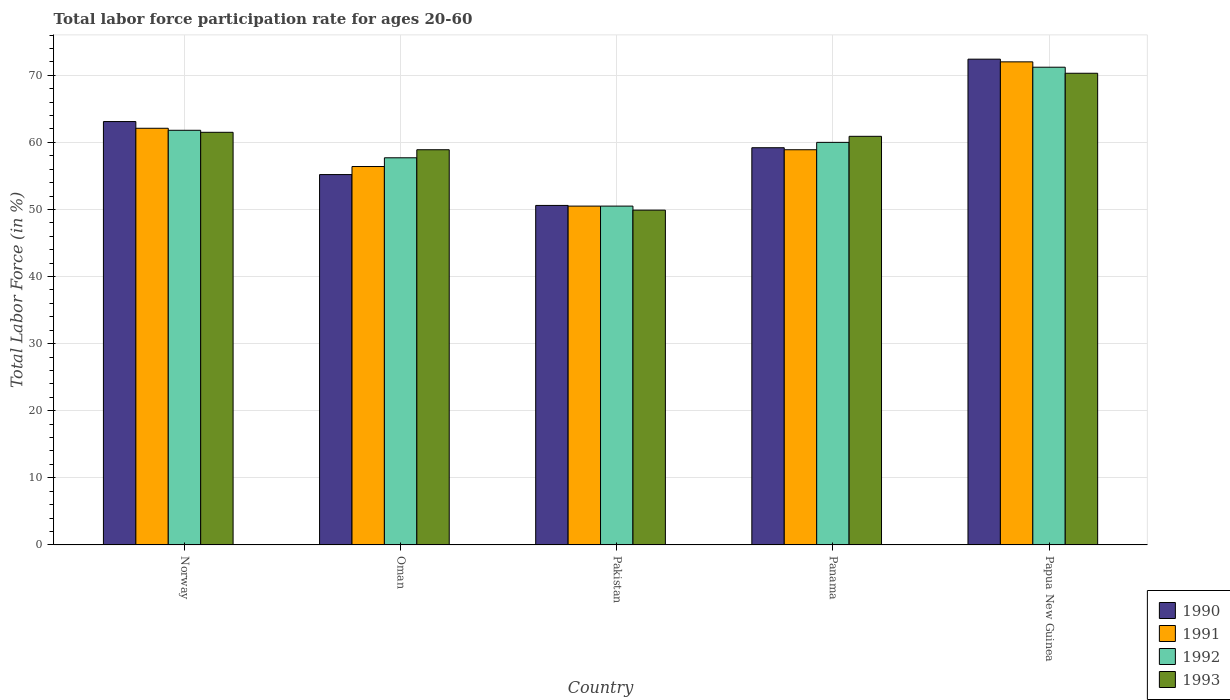Are the number of bars per tick equal to the number of legend labels?
Provide a short and direct response. Yes. Are the number of bars on each tick of the X-axis equal?
Provide a short and direct response. Yes. What is the label of the 5th group of bars from the left?
Your response must be concise. Papua New Guinea. In how many cases, is the number of bars for a given country not equal to the number of legend labels?
Offer a very short reply. 0. What is the labor force participation rate in 1991 in Panama?
Offer a very short reply. 58.9. Across all countries, what is the maximum labor force participation rate in 1990?
Provide a short and direct response. 72.4. Across all countries, what is the minimum labor force participation rate in 1993?
Make the answer very short. 49.9. In which country was the labor force participation rate in 1993 maximum?
Make the answer very short. Papua New Guinea. What is the total labor force participation rate in 1993 in the graph?
Offer a very short reply. 301.5. What is the difference between the labor force participation rate in 1992 in Panama and the labor force participation rate in 1991 in Papua New Guinea?
Offer a terse response. -12. What is the average labor force participation rate in 1990 per country?
Your answer should be compact. 60.1. What is the difference between the labor force participation rate of/in 1993 and labor force participation rate of/in 1990 in Oman?
Your answer should be very brief. 3.7. In how many countries, is the labor force participation rate in 1993 greater than 54 %?
Your answer should be very brief. 4. What is the ratio of the labor force participation rate in 1991 in Oman to that in Panama?
Keep it short and to the point. 0.96. What is the difference between the highest and the second highest labor force participation rate in 1991?
Keep it short and to the point. 13.1. What is the difference between the highest and the lowest labor force participation rate in 1992?
Provide a short and direct response. 20.7. Is the sum of the labor force participation rate in 1992 in Norway and Oman greater than the maximum labor force participation rate in 1993 across all countries?
Make the answer very short. Yes. How many bars are there?
Offer a terse response. 20. How many countries are there in the graph?
Your answer should be compact. 5. What is the difference between two consecutive major ticks on the Y-axis?
Ensure brevity in your answer.  10. Are the values on the major ticks of Y-axis written in scientific E-notation?
Provide a succinct answer. No. What is the title of the graph?
Provide a succinct answer. Total labor force participation rate for ages 20-60. What is the Total Labor Force (in %) of 1990 in Norway?
Your answer should be very brief. 63.1. What is the Total Labor Force (in %) in 1991 in Norway?
Give a very brief answer. 62.1. What is the Total Labor Force (in %) of 1992 in Norway?
Your answer should be compact. 61.8. What is the Total Labor Force (in %) of 1993 in Norway?
Provide a short and direct response. 61.5. What is the Total Labor Force (in %) in 1990 in Oman?
Provide a short and direct response. 55.2. What is the Total Labor Force (in %) in 1991 in Oman?
Your response must be concise. 56.4. What is the Total Labor Force (in %) of 1992 in Oman?
Offer a terse response. 57.7. What is the Total Labor Force (in %) of 1993 in Oman?
Offer a very short reply. 58.9. What is the Total Labor Force (in %) in 1990 in Pakistan?
Provide a short and direct response. 50.6. What is the Total Labor Force (in %) in 1991 in Pakistan?
Offer a terse response. 50.5. What is the Total Labor Force (in %) of 1992 in Pakistan?
Keep it short and to the point. 50.5. What is the Total Labor Force (in %) of 1993 in Pakistan?
Ensure brevity in your answer.  49.9. What is the Total Labor Force (in %) of 1990 in Panama?
Make the answer very short. 59.2. What is the Total Labor Force (in %) in 1991 in Panama?
Keep it short and to the point. 58.9. What is the Total Labor Force (in %) of 1992 in Panama?
Provide a short and direct response. 60. What is the Total Labor Force (in %) of 1993 in Panama?
Offer a terse response. 60.9. What is the Total Labor Force (in %) in 1990 in Papua New Guinea?
Provide a short and direct response. 72.4. What is the Total Labor Force (in %) of 1992 in Papua New Guinea?
Your response must be concise. 71.2. What is the Total Labor Force (in %) of 1993 in Papua New Guinea?
Make the answer very short. 70.3. Across all countries, what is the maximum Total Labor Force (in %) in 1990?
Your answer should be very brief. 72.4. Across all countries, what is the maximum Total Labor Force (in %) of 1991?
Provide a short and direct response. 72. Across all countries, what is the maximum Total Labor Force (in %) in 1992?
Offer a very short reply. 71.2. Across all countries, what is the maximum Total Labor Force (in %) of 1993?
Your response must be concise. 70.3. Across all countries, what is the minimum Total Labor Force (in %) of 1990?
Offer a very short reply. 50.6. Across all countries, what is the minimum Total Labor Force (in %) of 1991?
Provide a short and direct response. 50.5. Across all countries, what is the minimum Total Labor Force (in %) in 1992?
Provide a succinct answer. 50.5. Across all countries, what is the minimum Total Labor Force (in %) in 1993?
Provide a succinct answer. 49.9. What is the total Total Labor Force (in %) in 1990 in the graph?
Keep it short and to the point. 300.5. What is the total Total Labor Force (in %) in 1991 in the graph?
Offer a very short reply. 299.9. What is the total Total Labor Force (in %) of 1992 in the graph?
Your answer should be compact. 301.2. What is the total Total Labor Force (in %) in 1993 in the graph?
Your answer should be compact. 301.5. What is the difference between the Total Labor Force (in %) in 1993 in Norway and that in Oman?
Provide a short and direct response. 2.6. What is the difference between the Total Labor Force (in %) of 1991 in Norway and that in Pakistan?
Make the answer very short. 11.6. What is the difference between the Total Labor Force (in %) in 1992 in Norway and that in Pakistan?
Ensure brevity in your answer.  11.3. What is the difference between the Total Labor Force (in %) of 1991 in Norway and that in Panama?
Give a very brief answer. 3.2. What is the difference between the Total Labor Force (in %) in 1993 in Norway and that in Panama?
Your answer should be very brief. 0.6. What is the difference between the Total Labor Force (in %) of 1990 in Norway and that in Papua New Guinea?
Provide a succinct answer. -9.3. What is the difference between the Total Labor Force (in %) of 1991 in Norway and that in Papua New Guinea?
Offer a very short reply. -9.9. What is the difference between the Total Labor Force (in %) in 1992 in Norway and that in Papua New Guinea?
Give a very brief answer. -9.4. What is the difference between the Total Labor Force (in %) in 1991 in Oman and that in Pakistan?
Provide a short and direct response. 5.9. What is the difference between the Total Labor Force (in %) in 1993 in Oman and that in Pakistan?
Your answer should be very brief. 9. What is the difference between the Total Labor Force (in %) in 1990 in Oman and that in Panama?
Your answer should be compact. -4. What is the difference between the Total Labor Force (in %) of 1992 in Oman and that in Panama?
Provide a short and direct response. -2.3. What is the difference between the Total Labor Force (in %) of 1993 in Oman and that in Panama?
Give a very brief answer. -2. What is the difference between the Total Labor Force (in %) in 1990 in Oman and that in Papua New Guinea?
Give a very brief answer. -17.2. What is the difference between the Total Labor Force (in %) of 1991 in Oman and that in Papua New Guinea?
Your answer should be compact. -15.6. What is the difference between the Total Labor Force (in %) of 1991 in Pakistan and that in Panama?
Make the answer very short. -8.4. What is the difference between the Total Labor Force (in %) of 1992 in Pakistan and that in Panama?
Your answer should be very brief. -9.5. What is the difference between the Total Labor Force (in %) in 1990 in Pakistan and that in Papua New Guinea?
Offer a very short reply. -21.8. What is the difference between the Total Labor Force (in %) in 1991 in Pakistan and that in Papua New Guinea?
Your answer should be compact. -21.5. What is the difference between the Total Labor Force (in %) of 1992 in Pakistan and that in Papua New Guinea?
Provide a short and direct response. -20.7. What is the difference between the Total Labor Force (in %) in 1993 in Pakistan and that in Papua New Guinea?
Keep it short and to the point. -20.4. What is the difference between the Total Labor Force (in %) in 1990 in Panama and that in Papua New Guinea?
Your response must be concise. -13.2. What is the difference between the Total Labor Force (in %) of 1991 in Panama and that in Papua New Guinea?
Offer a terse response. -13.1. What is the difference between the Total Labor Force (in %) of 1992 in Panama and that in Papua New Guinea?
Keep it short and to the point. -11.2. What is the difference between the Total Labor Force (in %) of 1990 in Norway and the Total Labor Force (in %) of 1992 in Oman?
Your answer should be compact. 5.4. What is the difference between the Total Labor Force (in %) of 1990 in Norway and the Total Labor Force (in %) of 1993 in Oman?
Your response must be concise. 4.2. What is the difference between the Total Labor Force (in %) in 1991 in Norway and the Total Labor Force (in %) in 1993 in Oman?
Give a very brief answer. 3.2. What is the difference between the Total Labor Force (in %) in 1992 in Norway and the Total Labor Force (in %) in 1993 in Oman?
Provide a succinct answer. 2.9. What is the difference between the Total Labor Force (in %) in 1990 in Norway and the Total Labor Force (in %) in 1991 in Pakistan?
Your answer should be very brief. 12.6. What is the difference between the Total Labor Force (in %) of 1990 in Norway and the Total Labor Force (in %) of 1992 in Pakistan?
Your answer should be very brief. 12.6. What is the difference between the Total Labor Force (in %) in 1991 in Norway and the Total Labor Force (in %) in 1992 in Pakistan?
Ensure brevity in your answer.  11.6. What is the difference between the Total Labor Force (in %) of 1991 in Norway and the Total Labor Force (in %) of 1993 in Pakistan?
Offer a terse response. 12.2. What is the difference between the Total Labor Force (in %) in 1990 in Norway and the Total Labor Force (in %) in 1993 in Panama?
Offer a very short reply. 2.2. What is the difference between the Total Labor Force (in %) in 1992 in Norway and the Total Labor Force (in %) in 1993 in Panama?
Ensure brevity in your answer.  0.9. What is the difference between the Total Labor Force (in %) in 1991 in Norway and the Total Labor Force (in %) in 1992 in Papua New Guinea?
Make the answer very short. -9.1. What is the difference between the Total Labor Force (in %) of 1992 in Norway and the Total Labor Force (in %) of 1993 in Papua New Guinea?
Keep it short and to the point. -8.5. What is the difference between the Total Labor Force (in %) of 1990 in Oman and the Total Labor Force (in %) of 1991 in Pakistan?
Offer a terse response. 4.7. What is the difference between the Total Labor Force (in %) in 1990 in Oman and the Total Labor Force (in %) in 1992 in Pakistan?
Your response must be concise. 4.7. What is the difference between the Total Labor Force (in %) of 1990 in Oman and the Total Labor Force (in %) of 1993 in Pakistan?
Your response must be concise. 5.3. What is the difference between the Total Labor Force (in %) in 1991 in Oman and the Total Labor Force (in %) in 1993 in Pakistan?
Provide a succinct answer. 6.5. What is the difference between the Total Labor Force (in %) in 1992 in Oman and the Total Labor Force (in %) in 1993 in Pakistan?
Your answer should be very brief. 7.8. What is the difference between the Total Labor Force (in %) in 1990 in Oman and the Total Labor Force (in %) in 1991 in Panama?
Ensure brevity in your answer.  -3.7. What is the difference between the Total Labor Force (in %) in 1991 in Oman and the Total Labor Force (in %) in 1993 in Panama?
Your response must be concise. -4.5. What is the difference between the Total Labor Force (in %) in 1992 in Oman and the Total Labor Force (in %) in 1993 in Panama?
Provide a short and direct response. -3.2. What is the difference between the Total Labor Force (in %) in 1990 in Oman and the Total Labor Force (in %) in 1991 in Papua New Guinea?
Provide a succinct answer. -16.8. What is the difference between the Total Labor Force (in %) of 1990 in Oman and the Total Labor Force (in %) of 1993 in Papua New Guinea?
Ensure brevity in your answer.  -15.1. What is the difference between the Total Labor Force (in %) of 1991 in Oman and the Total Labor Force (in %) of 1992 in Papua New Guinea?
Your answer should be compact. -14.8. What is the difference between the Total Labor Force (in %) in 1990 in Pakistan and the Total Labor Force (in %) in 1993 in Panama?
Provide a succinct answer. -10.3. What is the difference between the Total Labor Force (in %) in 1992 in Pakistan and the Total Labor Force (in %) in 1993 in Panama?
Give a very brief answer. -10.4. What is the difference between the Total Labor Force (in %) in 1990 in Pakistan and the Total Labor Force (in %) in 1991 in Papua New Guinea?
Your answer should be compact. -21.4. What is the difference between the Total Labor Force (in %) of 1990 in Pakistan and the Total Labor Force (in %) of 1992 in Papua New Guinea?
Keep it short and to the point. -20.6. What is the difference between the Total Labor Force (in %) in 1990 in Pakistan and the Total Labor Force (in %) in 1993 in Papua New Guinea?
Your answer should be very brief. -19.7. What is the difference between the Total Labor Force (in %) of 1991 in Pakistan and the Total Labor Force (in %) of 1992 in Papua New Guinea?
Offer a terse response. -20.7. What is the difference between the Total Labor Force (in %) in 1991 in Pakistan and the Total Labor Force (in %) in 1993 in Papua New Guinea?
Make the answer very short. -19.8. What is the difference between the Total Labor Force (in %) of 1992 in Pakistan and the Total Labor Force (in %) of 1993 in Papua New Guinea?
Make the answer very short. -19.8. What is the difference between the Total Labor Force (in %) in 1990 in Panama and the Total Labor Force (in %) in 1991 in Papua New Guinea?
Your answer should be compact. -12.8. What is the difference between the Total Labor Force (in %) of 1990 in Panama and the Total Labor Force (in %) of 1992 in Papua New Guinea?
Keep it short and to the point. -12. What is the difference between the Total Labor Force (in %) in 1990 in Panama and the Total Labor Force (in %) in 1993 in Papua New Guinea?
Give a very brief answer. -11.1. What is the difference between the Total Labor Force (in %) of 1991 in Panama and the Total Labor Force (in %) of 1992 in Papua New Guinea?
Your answer should be very brief. -12.3. What is the difference between the Total Labor Force (in %) of 1992 in Panama and the Total Labor Force (in %) of 1993 in Papua New Guinea?
Ensure brevity in your answer.  -10.3. What is the average Total Labor Force (in %) of 1990 per country?
Your response must be concise. 60.1. What is the average Total Labor Force (in %) of 1991 per country?
Make the answer very short. 59.98. What is the average Total Labor Force (in %) in 1992 per country?
Your response must be concise. 60.24. What is the average Total Labor Force (in %) of 1993 per country?
Provide a short and direct response. 60.3. What is the difference between the Total Labor Force (in %) of 1990 and Total Labor Force (in %) of 1991 in Norway?
Ensure brevity in your answer.  1. What is the difference between the Total Labor Force (in %) in 1990 and Total Labor Force (in %) in 1992 in Norway?
Keep it short and to the point. 1.3. What is the difference between the Total Labor Force (in %) of 1992 and Total Labor Force (in %) of 1993 in Norway?
Your answer should be very brief. 0.3. What is the difference between the Total Labor Force (in %) of 1990 and Total Labor Force (in %) of 1992 in Oman?
Keep it short and to the point. -2.5. What is the difference between the Total Labor Force (in %) in 1990 and Total Labor Force (in %) in 1993 in Oman?
Your answer should be compact. -3.7. What is the difference between the Total Labor Force (in %) in 1991 and Total Labor Force (in %) in 1992 in Oman?
Give a very brief answer. -1.3. What is the difference between the Total Labor Force (in %) of 1990 and Total Labor Force (in %) of 1991 in Pakistan?
Provide a short and direct response. 0.1. What is the difference between the Total Labor Force (in %) of 1990 and Total Labor Force (in %) of 1992 in Pakistan?
Your answer should be compact. 0.1. What is the difference between the Total Labor Force (in %) in 1990 and Total Labor Force (in %) in 1993 in Pakistan?
Offer a very short reply. 0.7. What is the difference between the Total Labor Force (in %) of 1991 and Total Labor Force (in %) of 1993 in Pakistan?
Make the answer very short. 0.6. What is the difference between the Total Labor Force (in %) of 1990 and Total Labor Force (in %) of 1992 in Panama?
Your response must be concise. -0.8. What is the difference between the Total Labor Force (in %) of 1990 and Total Labor Force (in %) of 1993 in Panama?
Keep it short and to the point. -1.7. What is the difference between the Total Labor Force (in %) in 1991 and Total Labor Force (in %) in 1992 in Panama?
Keep it short and to the point. -1.1. What is the difference between the Total Labor Force (in %) of 1990 and Total Labor Force (in %) of 1991 in Papua New Guinea?
Your answer should be very brief. 0.4. What is the difference between the Total Labor Force (in %) of 1990 and Total Labor Force (in %) of 1992 in Papua New Guinea?
Your answer should be very brief. 1.2. What is the difference between the Total Labor Force (in %) of 1992 and Total Labor Force (in %) of 1993 in Papua New Guinea?
Ensure brevity in your answer.  0.9. What is the ratio of the Total Labor Force (in %) of 1990 in Norway to that in Oman?
Your response must be concise. 1.14. What is the ratio of the Total Labor Force (in %) in 1991 in Norway to that in Oman?
Offer a very short reply. 1.1. What is the ratio of the Total Labor Force (in %) in 1992 in Norway to that in Oman?
Your answer should be compact. 1.07. What is the ratio of the Total Labor Force (in %) of 1993 in Norway to that in Oman?
Provide a short and direct response. 1.04. What is the ratio of the Total Labor Force (in %) of 1990 in Norway to that in Pakistan?
Offer a terse response. 1.25. What is the ratio of the Total Labor Force (in %) in 1991 in Norway to that in Pakistan?
Offer a terse response. 1.23. What is the ratio of the Total Labor Force (in %) of 1992 in Norway to that in Pakistan?
Offer a terse response. 1.22. What is the ratio of the Total Labor Force (in %) in 1993 in Norway to that in Pakistan?
Your response must be concise. 1.23. What is the ratio of the Total Labor Force (in %) in 1990 in Norway to that in Panama?
Your response must be concise. 1.07. What is the ratio of the Total Labor Force (in %) of 1991 in Norway to that in Panama?
Offer a very short reply. 1.05. What is the ratio of the Total Labor Force (in %) in 1992 in Norway to that in Panama?
Provide a succinct answer. 1.03. What is the ratio of the Total Labor Force (in %) of 1993 in Norway to that in Panama?
Your answer should be very brief. 1.01. What is the ratio of the Total Labor Force (in %) in 1990 in Norway to that in Papua New Guinea?
Your response must be concise. 0.87. What is the ratio of the Total Labor Force (in %) in 1991 in Norway to that in Papua New Guinea?
Provide a succinct answer. 0.86. What is the ratio of the Total Labor Force (in %) of 1992 in Norway to that in Papua New Guinea?
Provide a succinct answer. 0.87. What is the ratio of the Total Labor Force (in %) in 1993 in Norway to that in Papua New Guinea?
Your answer should be compact. 0.87. What is the ratio of the Total Labor Force (in %) in 1991 in Oman to that in Pakistan?
Provide a short and direct response. 1.12. What is the ratio of the Total Labor Force (in %) of 1992 in Oman to that in Pakistan?
Keep it short and to the point. 1.14. What is the ratio of the Total Labor Force (in %) in 1993 in Oman to that in Pakistan?
Offer a terse response. 1.18. What is the ratio of the Total Labor Force (in %) in 1990 in Oman to that in Panama?
Your answer should be very brief. 0.93. What is the ratio of the Total Labor Force (in %) in 1991 in Oman to that in Panama?
Offer a very short reply. 0.96. What is the ratio of the Total Labor Force (in %) in 1992 in Oman to that in Panama?
Provide a succinct answer. 0.96. What is the ratio of the Total Labor Force (in %) in 1993 in Oman to that in Panama?
Offer a very short reply. 0.97. What is the ratio of the Total Labor Force (in %) of 1990 in Oman to that in Papua New Guinea?
Offer a very short reply. 0.76. What is the ratio of the Total Labor Force (in %) of 1991 in Oman to that in Papua New Guinea?
Give a very brief answer. 0.78. What is the ratio of the Total Labor Force (in %) in 1992 in Oman to that in Papua New Guinea?
Ensure brevity in your answer.  0.81. What is the ratio of the Total Labor Force (in %) of 1993 in Oman to that in Papua New Guinea?
Your answer should be very brief. 0.84. What is the ratio of the Total Labor Force (in %) of 1990 in Pakistan to that in Panama?
Provide a succinct answer. 0.85. What is the ratio of the Total Labor Force (in %) in 1991 in Pakistan to that in Panama?
Your answer should be compact. 0.86. What is the ratio of the Total Labor Force (in %) in 1992 in Pakistan to that in Panama?
Your answer should be very brief. 0.84. What is the ratio of the Total Labor Force (in %) of 1993 in Pakistan to that in Panama?
Keep it short and to the point. 0.82. What is the ratio of the Total Labor Force (in %) in 1990 in Pakistan to that in Papua New Guinea?
Provide a short and direct response. 0.7. What is the ratio of the Total Labor Force (in %) of 1991 in Pakistan to that in Papua New Guinea?
Offer a very short reply. 0.7. What is the ratio of the Total Labor Force (in %) in 1992 in Pakistan to that in Papua New Guinea?
Ensure brevity in your answer.  0.71. What is the ratio of the Total Labor Force (in %) of 1993 in Pakistan to that in Papua New Guinea?
Your response must be concise. 0.71. What is the ratio of the Total Labor Force (in %) of 1990 in Panama to that in Papua New Guinea?
Your response must be concise. 0.82. What is the ratio of the Total Labor Force (in %) of 1991 in Panama to that in Papua New Guinea?
Give a very brief answer. 0.82. What is the ratio of the Total Labor Force (in %) of 1992 in Panama to that in Papua New Guinea?
Ensure brevity in your answer.  0.84. What is the ratio of the Total Labor Force (in %) of 1993 in Panama to that in Papua New Guinea?
Your answer should be compact. 0.87. What is the difference between the highest and the second highest Total Labor Force (in %) in 1991?
Your answer should be very brief. 9.9. What is the difference between the highest and the second highest Total Labor Force (in %) of 1993?
Offer a very short reply. 8.8. What is the difference between the highest and the lowest Total Labor Force (in %) of 1990?
Ensure brevity in your answer.  21.8. What is the difference between the highest and the lowest Total Labor Force (in %) of 1991?
Keep it short and to the point. 21.5. What is the difference between the highest and the lowest Total Labor Force (in %) in 1992?
Offer a terse response. 20.7. What is the difference between the highest and the lowest Total Labor Force (in %) in 1993?
Provide a succinct answer. 20.4. 